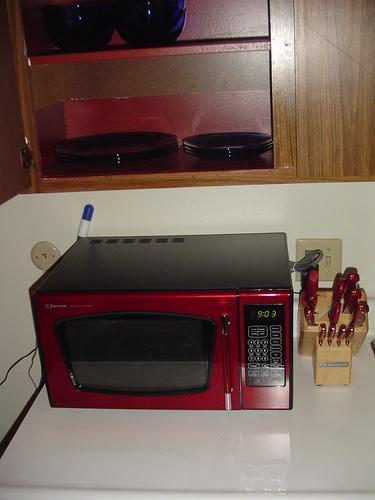How many microwaves are there?
Give a very brief answer. 1. How many bowls are there?
Give a very brief answer. 2. 